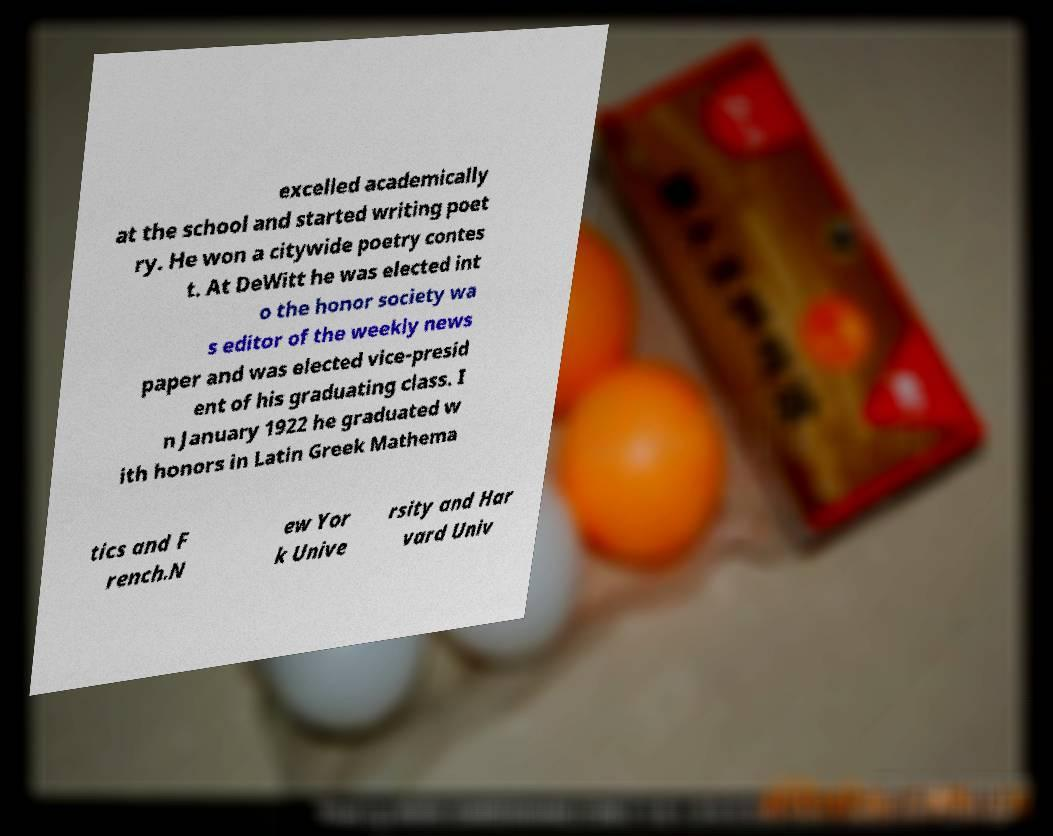Could you extract and type out the text from this image? excelled academically at the school and started writing poet ry. He won a citywide poetry contes t. At DeWitt he was elected int o the honor society wa s editor of the weekly news paper and was elected vice-presid ent of his graduating class. I n January 1922 he graduated w ith honors in Latin Greek Mathema tics and F rench.N ew Yor k Unive rsity and Har vard Univ 